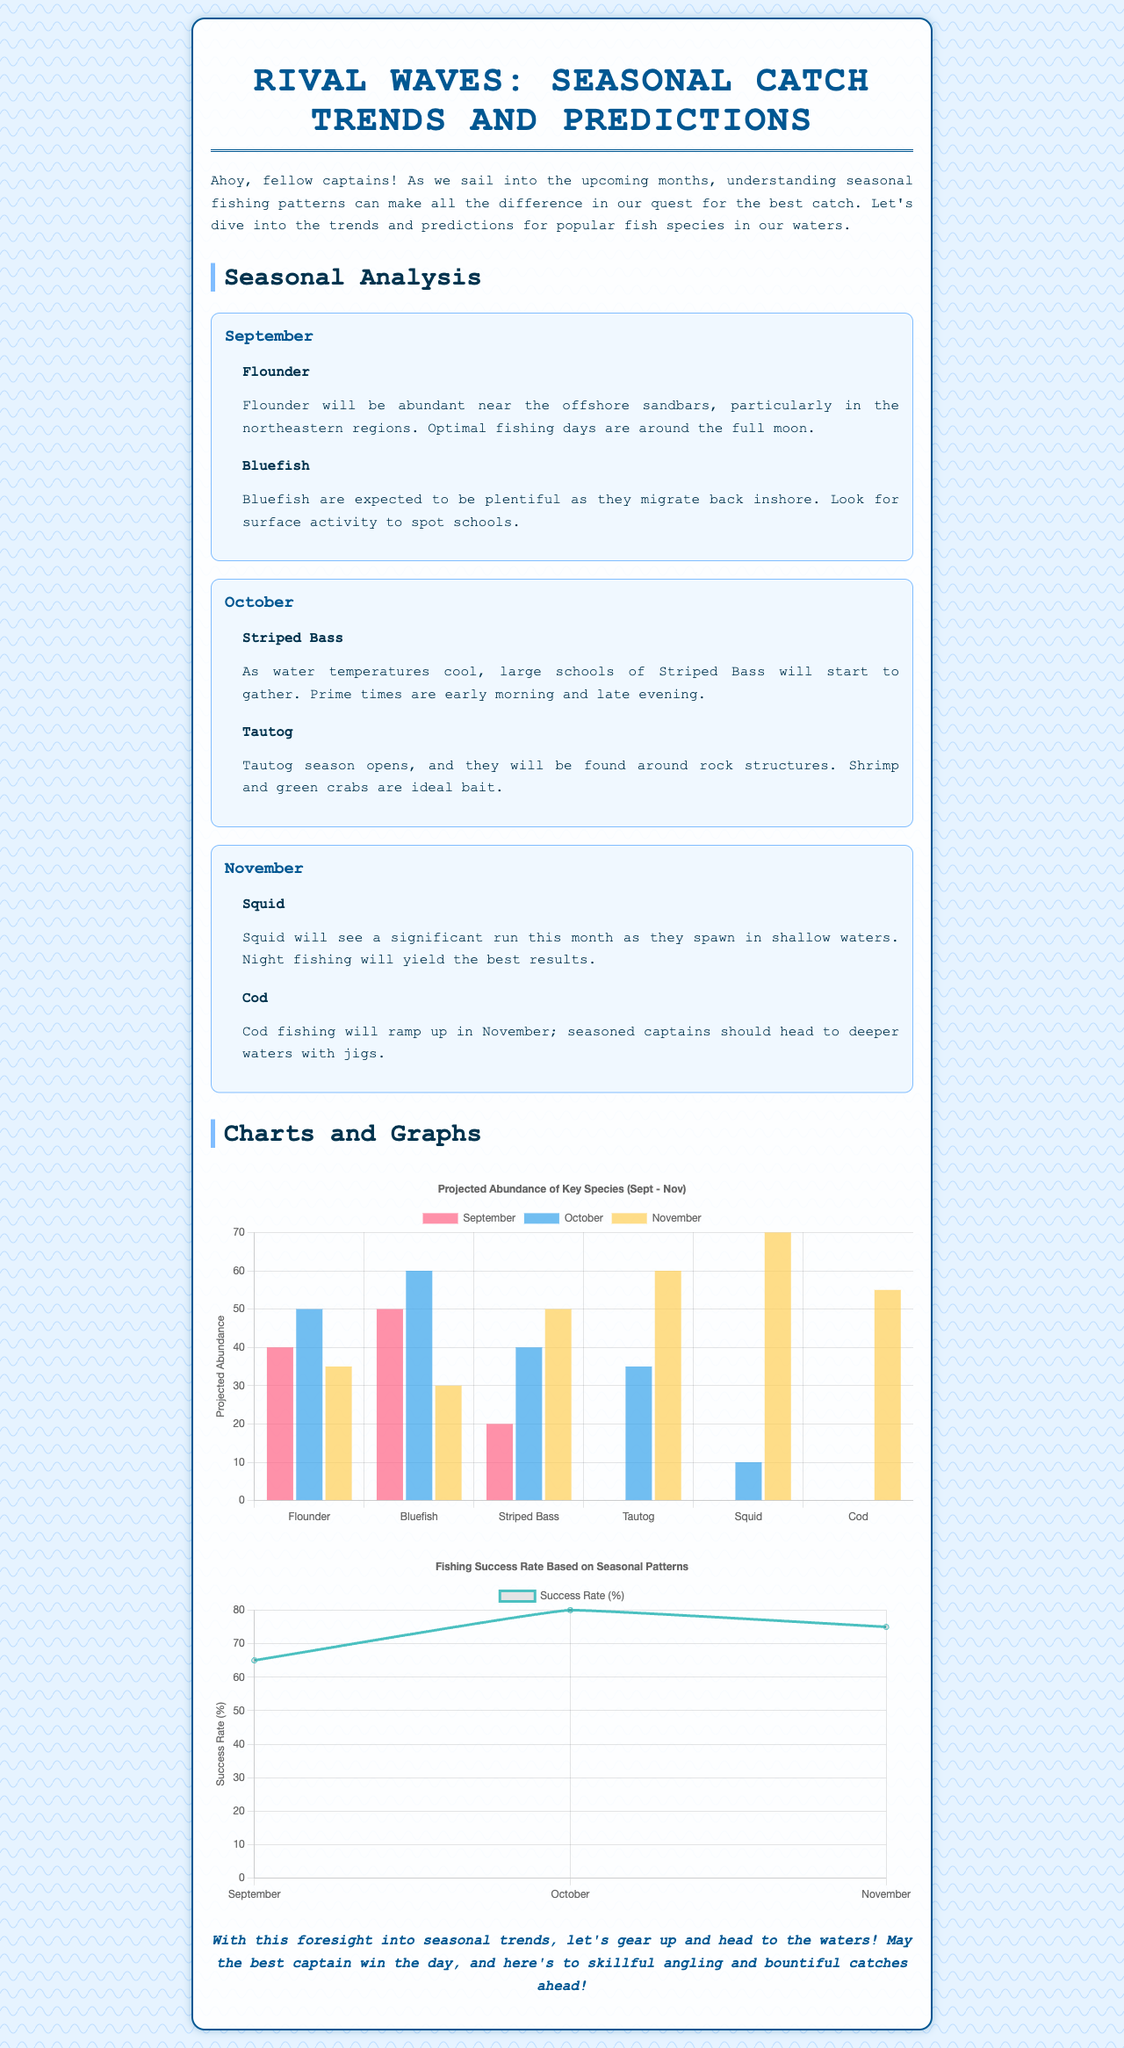What species is expected to be abundant in September? The document mentions that Flounder and Bluefish are expected to be abundant in September.
Answer: Flounder, Bluefish What are the prime times for Striped Bass fishing? The document states that prime times for Striped Bass fishing are early morning and late evening.
Answer: Early morning and late evening What month will see a significant run of Squid? The document indicates that Squid will have a significant run in November.
Answer: November How many species are projected to have an abundance of 60 or higher in November? By analyzing the chart, there are four species (Tautog, Squid, Cod) with an abundance of 60 or higher projected for November.
Answer: 3 What is the fishing success rate in October? According to the fishing success rate chart, the success rate for October is 80 percent.
Answer: 80 Which month has the highest projected abundance for Cod? The document indicates that the highest projected abundance for Cod is in November.
Answer: November What type of chart is used to represent fishing success rates? The document specifies that a line chart is used to represent fishing success rates.
Answer: Line chart In which month does Tautog season open? The document clearly states that Tautog season opens in October.
Answer: October 